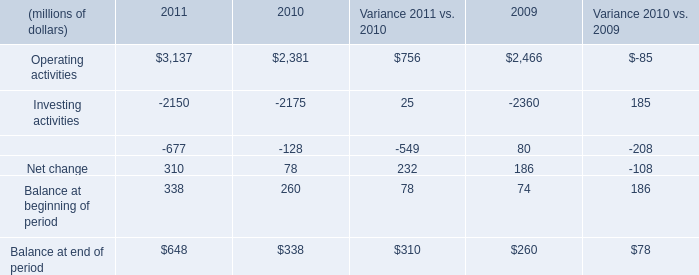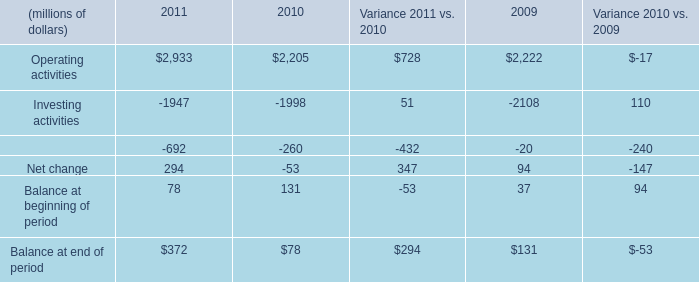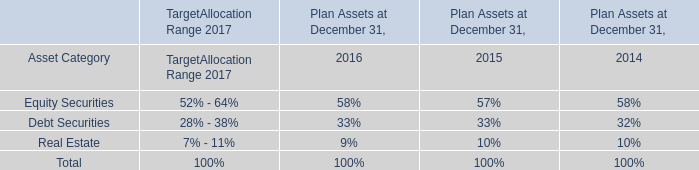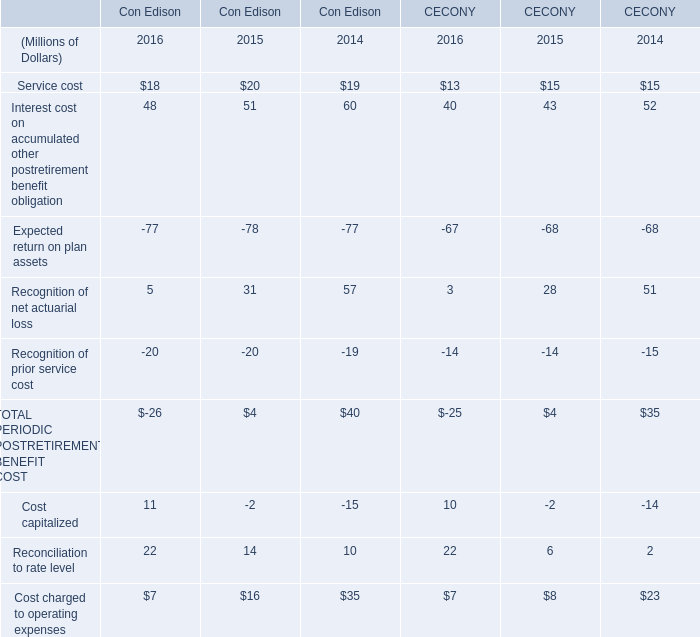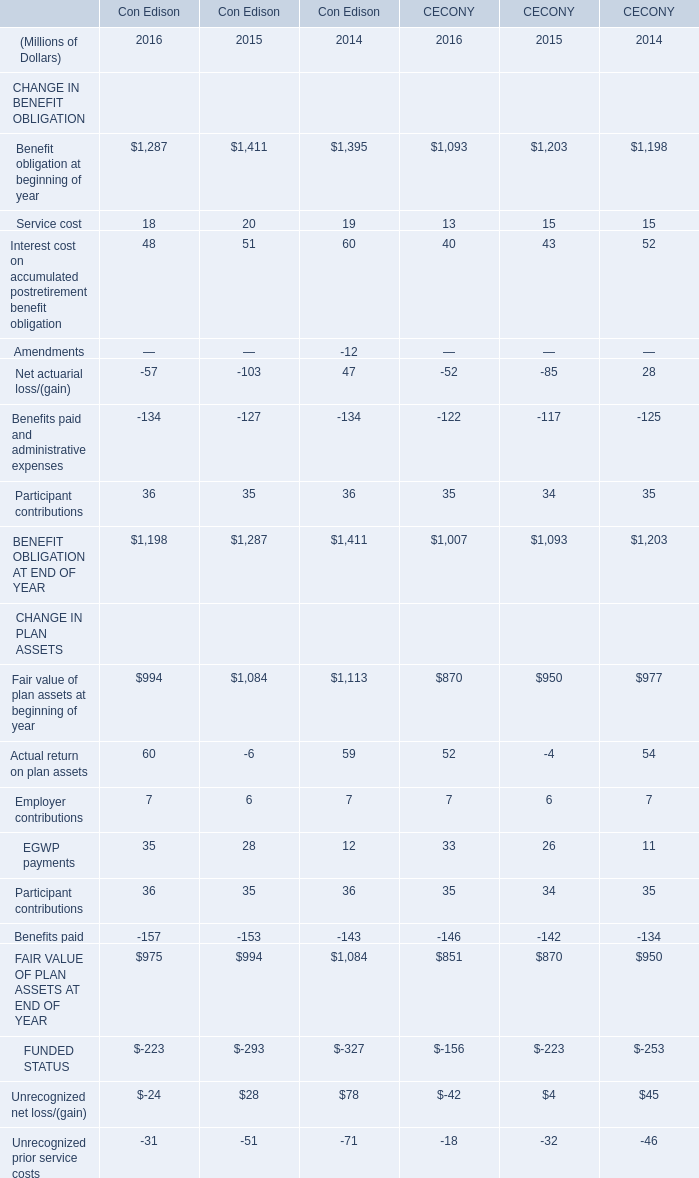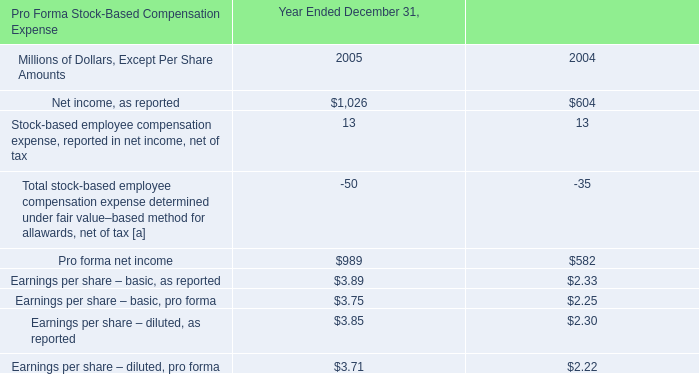what was the percentage difference of earnings per share 2013 basic pro forma compared to earnings per share 2013 diluted pro forma in 2005? 
Computations: ((3.75 - 3.71) / 3.75)
Answer: 0.01067. 